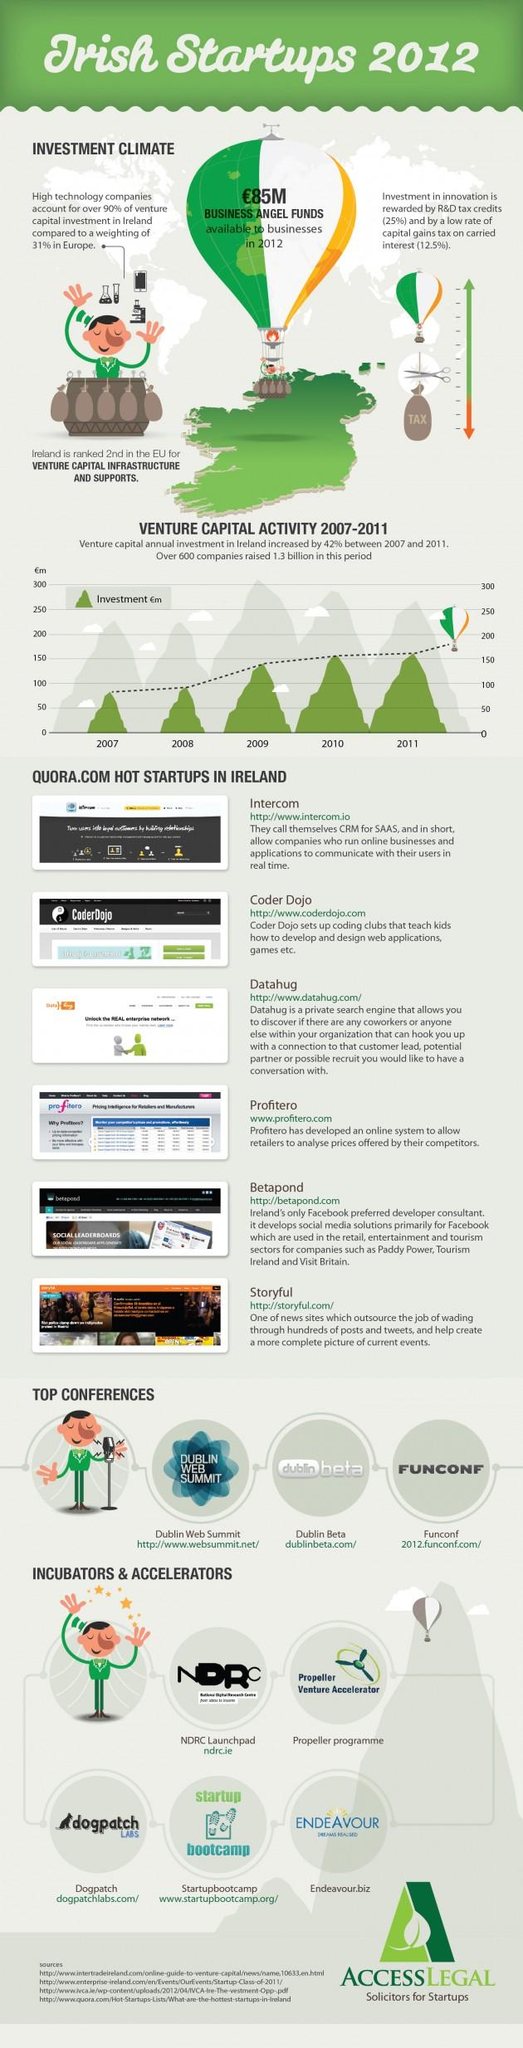Specify some key components in this picture. Dublin Beta is ranked second among the top conferences. Datahug is the third company listed on Quora.com's list of hot startups in Ireland. From 2007 to 2011, the investment was above 150 million pounds for a total of two years. Startupbootcamp is categorized as an incubator and accelerator organization. 